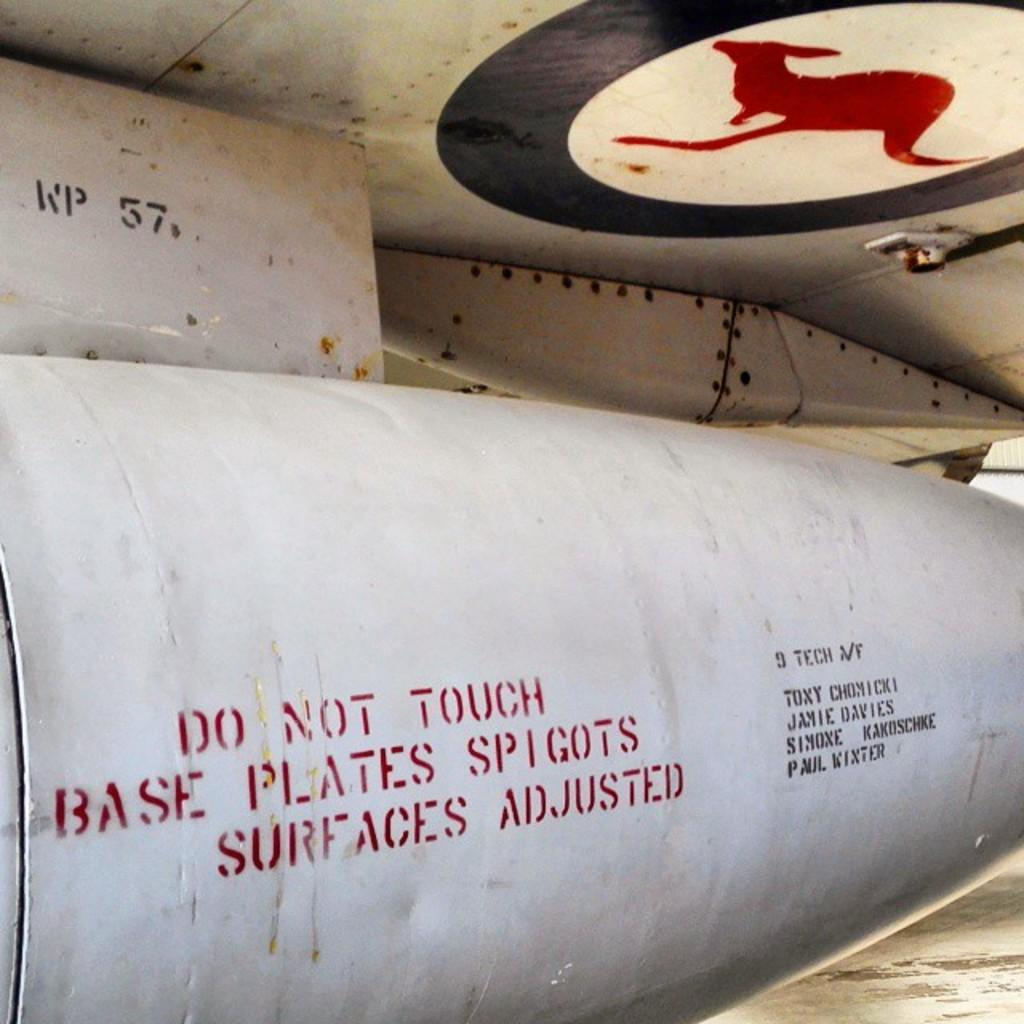<image>
Relay a brief, clear account of the picture shown. A large piece of machinery has a warning that says "Do not touch base plates spigots surfaces adjusted." 